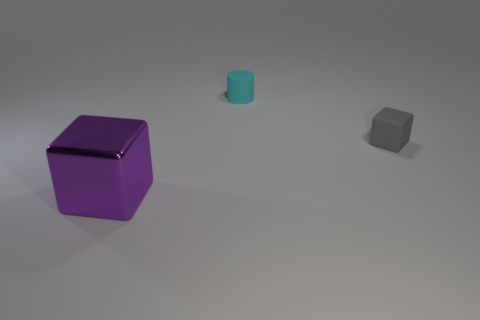What size is the rubber thing that is on the left side of the matte cube?
Make the answer very short. Small. What number of small objects are either cyan things or yellow shiny cubes?
Provide a succinct answer. 1. There is another object that is the same shape as the small gray rubber object; what color is it?
Your response must be concise. Purple. Do the purple cube and the gray block have the same size?
Make the answer very short. No. How many things are either tiny blue balls or objects that are in front of the cyan cylinder?
Provide a succinct answer. 2. There is a thing behind the block right of the metal thing; what is its color?
Your answer should be very brief. Cyan. There is a block left of the small cyan object; is its color the same as the small matte cylinder?
Provide a short and direct response. No. What is the material of the object that is to the right of the rubber cylinder?
Offer a very short reply. Rubber. The rubber cylinder is what size?
Offer a very short reply. Small. Do the thing behind the gray rubber cube and the small gray object have the same material?
Your answer should be very brief. Yes. 